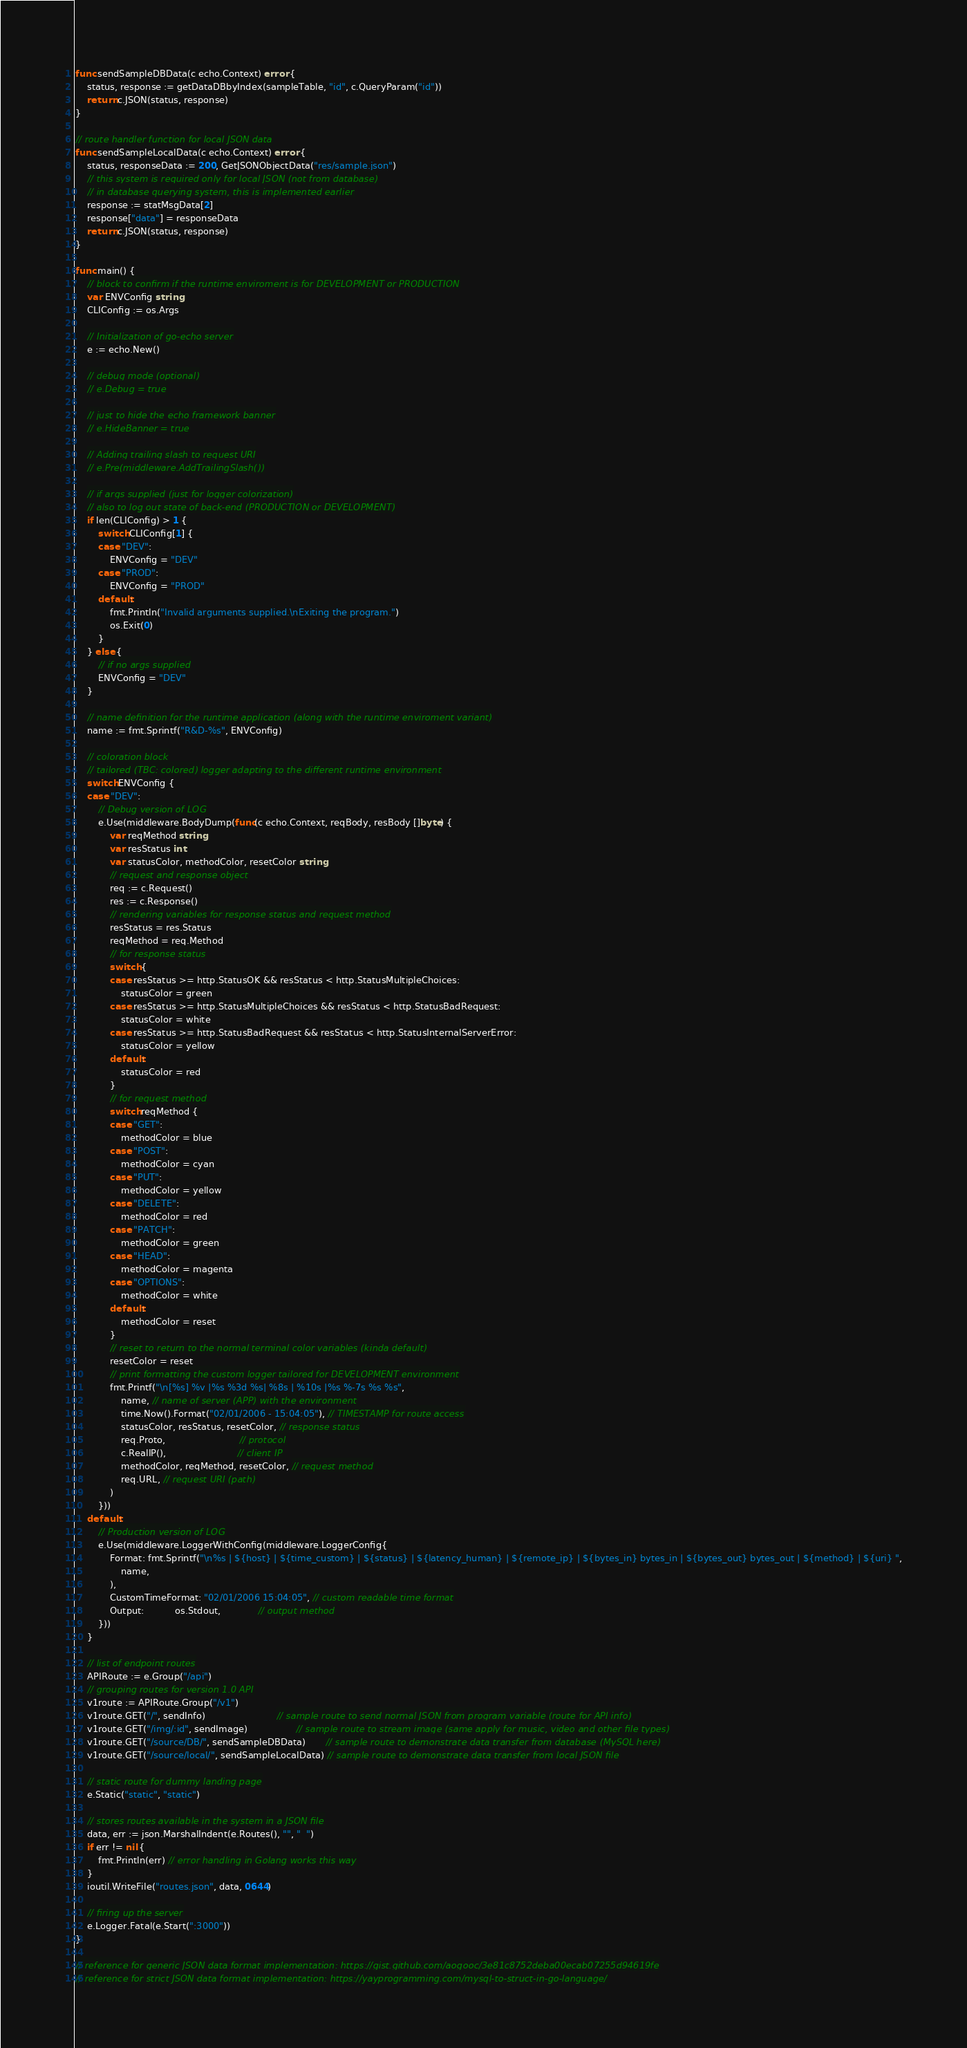Convert code to text. <code><loc_0><loc_0><loc_500><loc_500><_Go_>func sendSampleDBData(c echo.Context) error {
	status, response := getDataDBbyIndex(sampleTable, "id", c.QueryParam("id"))
	return c.JSON(status, response)
}

// route handler function for local JSON data
func sendSampleLocalData(c echo.Context) error {
	status, responseData := 200, GetJSONObjectData("res/sample.json")
	// this system is required only for local JSON (not from database)
	// in database querying system, this is implemented earlier
	response := statMsgData[2]
	response["data"] = responseData
	return c.JSON(status, response)
}

func main() {
	// block to confirm if the runtime enviroment is for DEVELOPMENT or PRODUCTION
	var ENVConfig string
	CLIConfig := os.Args

	// Initialization of go-echo server
	e := echo.New()

	// debug mode (optional)
	// e.Debug = true

	// just to hide the echo framework banner
	// e.HideBanner = true

	// Adding trailing slash to request URI
	// e.Pre(middleware.AddTrailingSlash())

	// if args supplied (just for logger colorization)
	// also to log out state of back-end (PRODUCTION or DEVELOPMENT)
	if len(CLIConfig) > 1 {
		switch CLIConfig[1] {
		case "DEV":
			ENVConfig = "DEV"
		case "PROD":
			ENVConfig = "PROD"
		default:
			fmt.Println("Invalid arguments supplied.\nExiting the program.")
			os.Exit(0)
		}
	} else {
		// if no args supplied
		ENVConfig = "DEV"
	}

	// name definition for the runtime application (along with the runtime enviroment variant)
	name := fmt.Sprintf("R&D-%s", ENVConfig)

	// coloration block
	// tailored (TBC: colored) logger adapting to the different runtime environment
	switch ENVConfig {
	case "DEV":
		// Debug version of LOG
		e.Use(middleware.BodyDump(func(c echo.Context, reqBody, resBody []byte) {
			var reqMethod string
			var resStatus int
			var statusColor, methodColor, resetColor string
			// request and response object
			req := c.Request()
			res := c.Response()
			// rendering variables for response status and request method
			resStatus = res.Status
			reqMethod = req.Method
			// for response status
			switch {
			case resStatus >= http.StatusOK && resStatus < http.StatusMultipleChoices:
				statusColor = green
			case resStatus >= http.StatusMultipleChoices && resStatus < http.StatusBadRequest:
				statusColor = white
			case resStatus >= http.StatusBadRequest && resStatus < http.StatusInternalServerError:
				statusColor = yellow
			default:
				statusColor = red
			}
			// for request method
			switch reqMethod {
			case "GET":
				methodColor = blue
			case "POST":
				methodColor = cyan
			case "PUT":
				methodColor = yellow
			case "DELETE":
				methodColor = red
			case "PATCH":
				methodColor = green
			case "HEAD":
				methodColor = magenta
			case "OPTIONS":
				methodColor = white
			default:
				methodColor = reset
			}
			// reset to return to the normal terminal color variables (kinda default)
			resetColor = reset
			// print formatting the custom logger tailored for DEVELOPMENT environment
			fmt.Printf("\n[%s] %v |%s %3d %s| %8s | %10s |%s %-7s %s %s",
				name, // name of server (APP) with the environment
				time.Now().Format("02/01/2006 - 15:04:05"), // TIMESTAMP for route access
				statusColor, resStatus, resetColor, // response status
				req.Proto,                          // protocol
				c.RealIP(),                         // client IP
				methodColor, reqMethod, resetColor, // request method
				req.URL, // request URI (path)
			)
		}))
	default:
		// Production version of LOG
		e.Use(middleware.LoggerWithConfig(middleware.LoggerConfig{
			Format: fmt.Sprintf("\n%s | ${host} | ${time_custom} | ${status} | ${latency_human} | ${remote_ip} | ${bytes_in} bytes_in | ${bytes_out} bytes_out | ${method} | ${uri} ",
				name,
			),
			CustomTimeFormat: "02/01/2006 15:04:05", // custom readable time format
			Output:           os.Stdout,             // output method
		}))
	}

	// list of endpoint routes
	APIRoute := e.Group("/api")
	// grouping routes for version 1.0 API
	v1route := APIRoute.Group("/v1")
	v1route.GET("/", sendInfo)                         // sample route to send normal JSON from program variable (route for API info)
	v1route.GET("/img/:id", sendImage)                 // sample route to stream image (same apply for music, video and other file types)
	v1route.GET("/source/DB/", sendSampleDBData)       // sample route to demonstrate data transfer from database (MySQL here)
	v1route.GET("/source/local/", sendSampleLocalData) // sample route to demonstrate data transfer from local JSON file

	// static route for dummy landing page
	e.Static("static", "static")

	// stores routes available in the system in a JSON file
	data, err := json.MarshalIndent(e.Routes(), "", "  ")
	if err != nil {
		fmt.Println(err) // error handling in Golang works this way
	}
	ioutil.WriteFile("routes.json", data, 0644)

	// firing up the server
	e.Logger.Fatal(e.Start(":3000"))
}

// reference for generic JSON data format implementation: https://gist.github.com/aogooc/3e81c8752deba00ecab07255d94619fe
// reference for strict JSON data format implementation: https://yayprogramming.com/mysql-to-struct-in-go-language/
</code> 